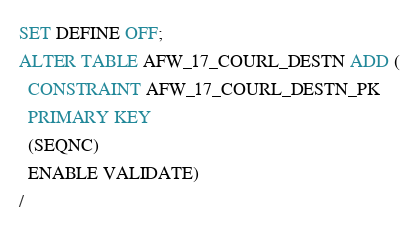<code> <loc_0><loc_0><loc_500><loc_500><_SQL_>SET DEFINE OFF;
ALTER TABLE AFW_17_COURL_DESTN ADD (
  CONSTRAINT AFW_17_COURL_DESTN_PK
  PRIMARY KEY
  (SEQNC)
  ENABLE VALIDATE)
/
</code> 